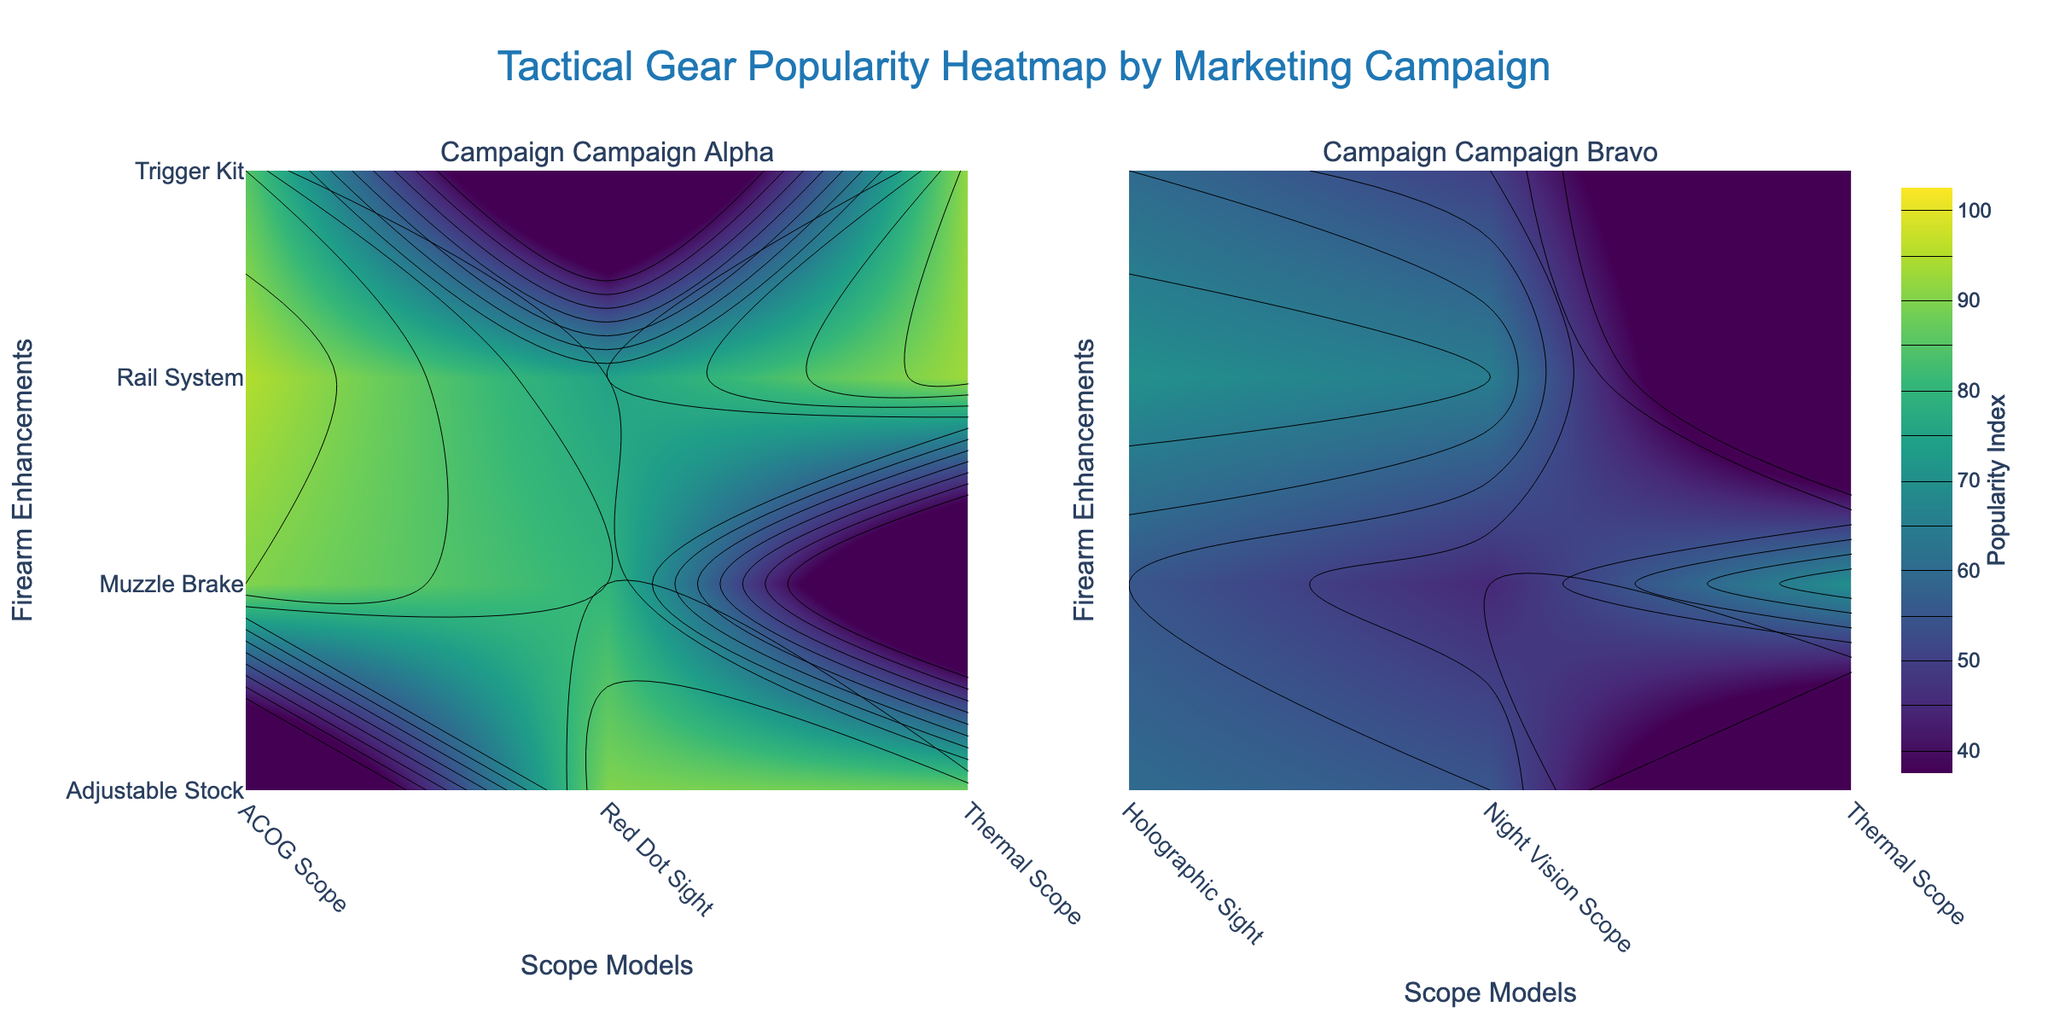What is the title of the figure? The title of the figure is prominently displayed at the top and reads: "Tactical Gear Popularity Heatmap by Marketing Campaign."
Answer: Tactical Gear Popularity Heatmap by Marketing Campaign Which marketing campaign has the highest 'Popularity Index' for any scope model? Look at the heatmap colors and contours for both campaigns; the highest 'Popularity Index' is indicated by the darkest color. Campaign Alpha shows a 'Popularity Index' of 95 for an ACOG scope.
Answer: Campaign Alpha Which 'Scope Models' and 'Firearm Enhancements' combination is the most popular in Campaign Bravo? Look at the heatmap for Campaign Bravo and identify the darkest contour region, indicating the highest 'Popularity Index'. The combination of 'Holographic Sight' and 'Muzzle Brake' yields a 'Popularity Index' of 70, which is the highest in Campaign Bravo.
Answer: Holographic Sight and Muzzle Brake What is the average 'Popularity Index' for Campaign Alpha across all combinations? Sum all the 'Popularity Index' values for Campaign Alpha and divide by the number of combinations. The values for Campaign Alpha are 75, 80, 85, 90, 95, 88, 92, 85, 90, and 93. Sum these to get 873 and divide by the number of data points (10).
Answer: 87.3 How does the popularity of 'Thermal Scope' compare between the two campaigns? Identify the 'Thermal Scope' on both heatmaps and check their 'Popularity Index' values. In Campaign Alpha, the 'Thermal Scope' has 'Popularity Index' values of 88, 92, and 93. In Campaign Bravo, it has a 'Popularity Index' of 70. The average for Campaign Alpha is higher.
Answer: Campaign Alpha is higher Which 'Firearm Enhancement' is associated with the highest 'Popularity Index' for Campaign Alpha's 'Red Dot Sight'? Look in the Campaign Alpha heatmap for the 'Red Dot Sight' across different 'Firearm Enhancements' and identify which combination has the highest 'Popularity Index'. The 'Red Dot Sight' with 'Adjustable Stock' has the highest index of 90.
Answer: Adjustable Stock For which marketing campaign do 'Adjustable Stocks' generally lead to higher popularity? Compare the 'Popularity Index' values for 'Adjustable Stocks' between the two campaigns. Campaign Alpha frequently has higher values (85, 88, 90), while Campaign Bravo has lower values (55, 60).
Answer: Campaign Alpha What trend do you observe with the popularity of 'Night Vision Scope' over time in Campaign Bravo? Examine the Campaign Bravo heatmap for 'Night Vision Scope' and observe changes over different enhancements and dates. Initially lower, but gaining slightly higher popularity over time.
Answer: Increasing slightly over time 